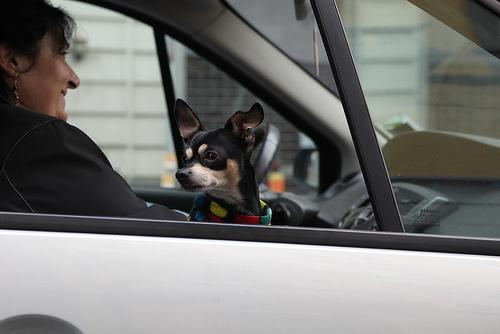Question: what animal is pictured?
Choices:
A. A cat.
B. A fish.
C. A dog.
D. A monkey.
Answer with the letter. Answer: C Question: where is the dog?
Choices:
A. By the car.
B. Behind the car.
C. Above the car.
D. In the car.
Answer with the letter. Answer: D Question: who is in the car with the dog?
Choices:
A. A man.
B. A boy.
C. A woman.
D. A girl.
Answer with the letter. Answer: C Question: what is the dog wearing on its neck?
Choices:
A. A bell.
B. A collar.
C. A band.
D. A funnel.
Answer with the letter. Answer: B Question: what color is the dog?
Choices:
A. Yellow.
B. Brown and black.
C. Orange.
D. Gray.
Answer with the letter. Answer: B 